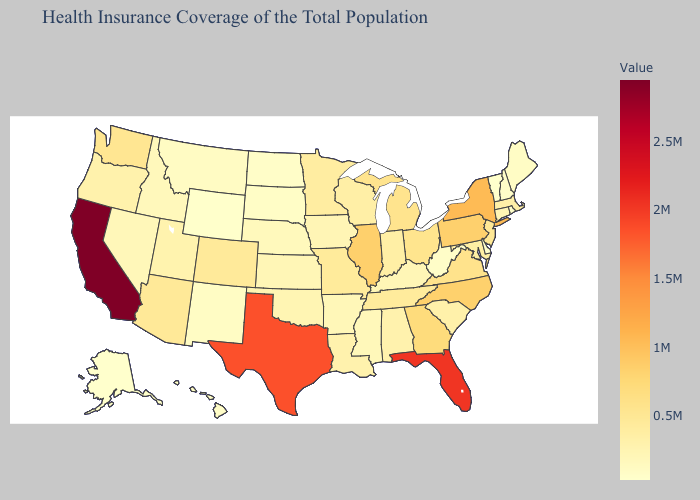Does Kentucky have the highest value in the South?
Be succinct. No. Which states have the highest value in the USA?
Short answer required. California. Among the states that border Pennsylvania , which have the highest value?
Answer briefly. New York. Among the states that border Oklahoma , does Kansas have the lowest value?
Answer briefly. No. Does California have the highest value in the USA?
Concise answer only. Yes. Does Alaska have a lower value than Pennsylvania?
Be succinct. Yes. 